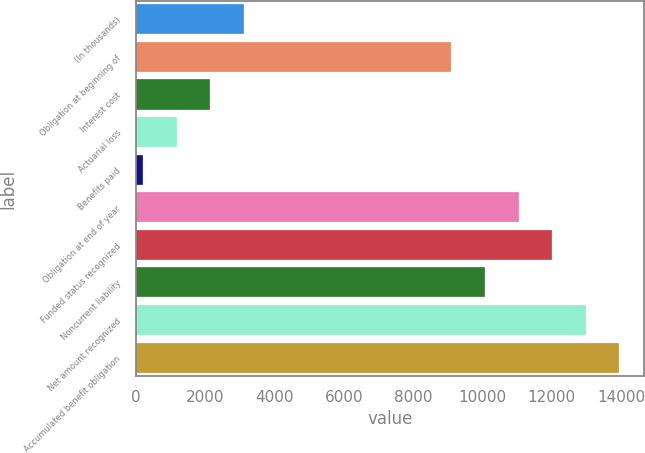<chart> <loc_0><loc_0><loc_500><loc_500><bar_chart><fcel>(In thousands)<fcel>Obligation at beginning of<fcel>Interest cost<fcel>Actuarial loss<fcel>Benefits paid<fcel>Obligation at end of year<fcel>Funded status recognized<fcel>Noncurrent liability<fcel>Net amount recognized<fcel>Accumulated benefit obligation<nl><fcel>3109<fcel>9105<fcel>2140<fcel>1171<fcel>202<fcel>11043<fcel>12012<fcel>10074<fcel>12981<fcel>13950<nl></chart> 